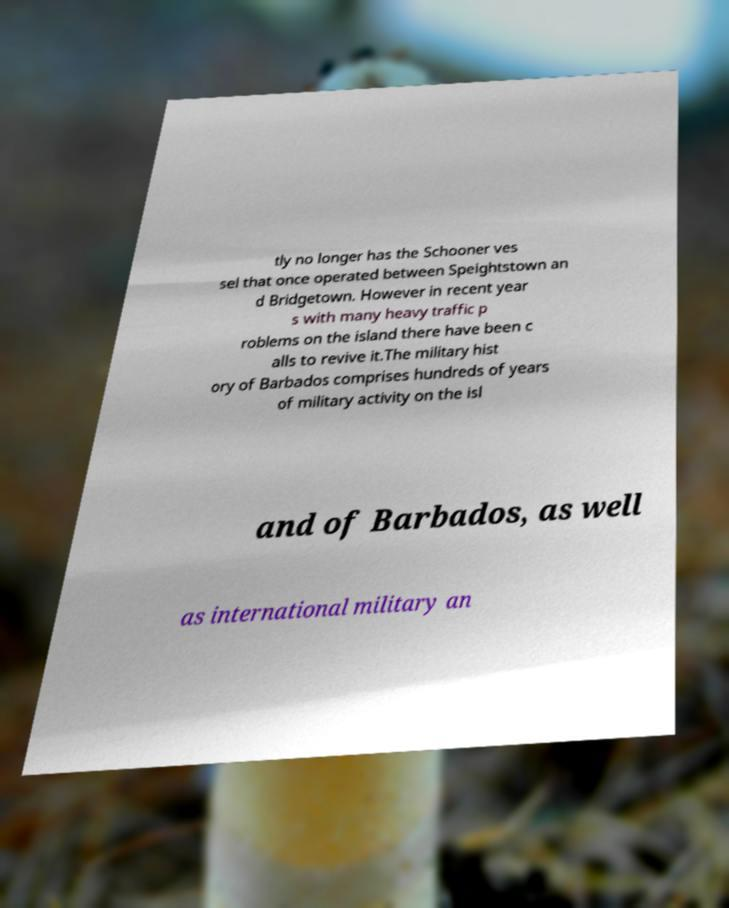Please identify and transcribe the text found in this image. tly no longer has the Schooner ves sel that once operated between Speightstown an d Bridgetown. However in recent year s with many heavy traffic p roblems on the island there have been c alls to revive it.The military hist ory of Barbados comprises hundreds of years of military activity on the isl and of Barbados, as well as international military an 